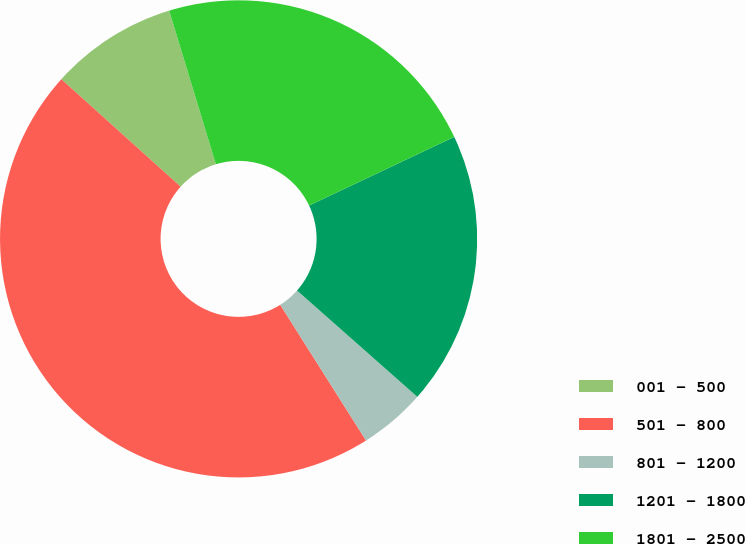Convert chart to OTSL. <chart><loc_0><loc_0><loc_500><loc_500><pie_chart><fcel>001 - 500<fcel>501 - 800<fcel>801 - 1200<fcel>1201 - 1800<fcel>1801 - 2500<nl><fcel>8.63%<fcel>45.64%<fcel>4.51%<fcel>18.55%<fcel>22.67%<nl></chart> 